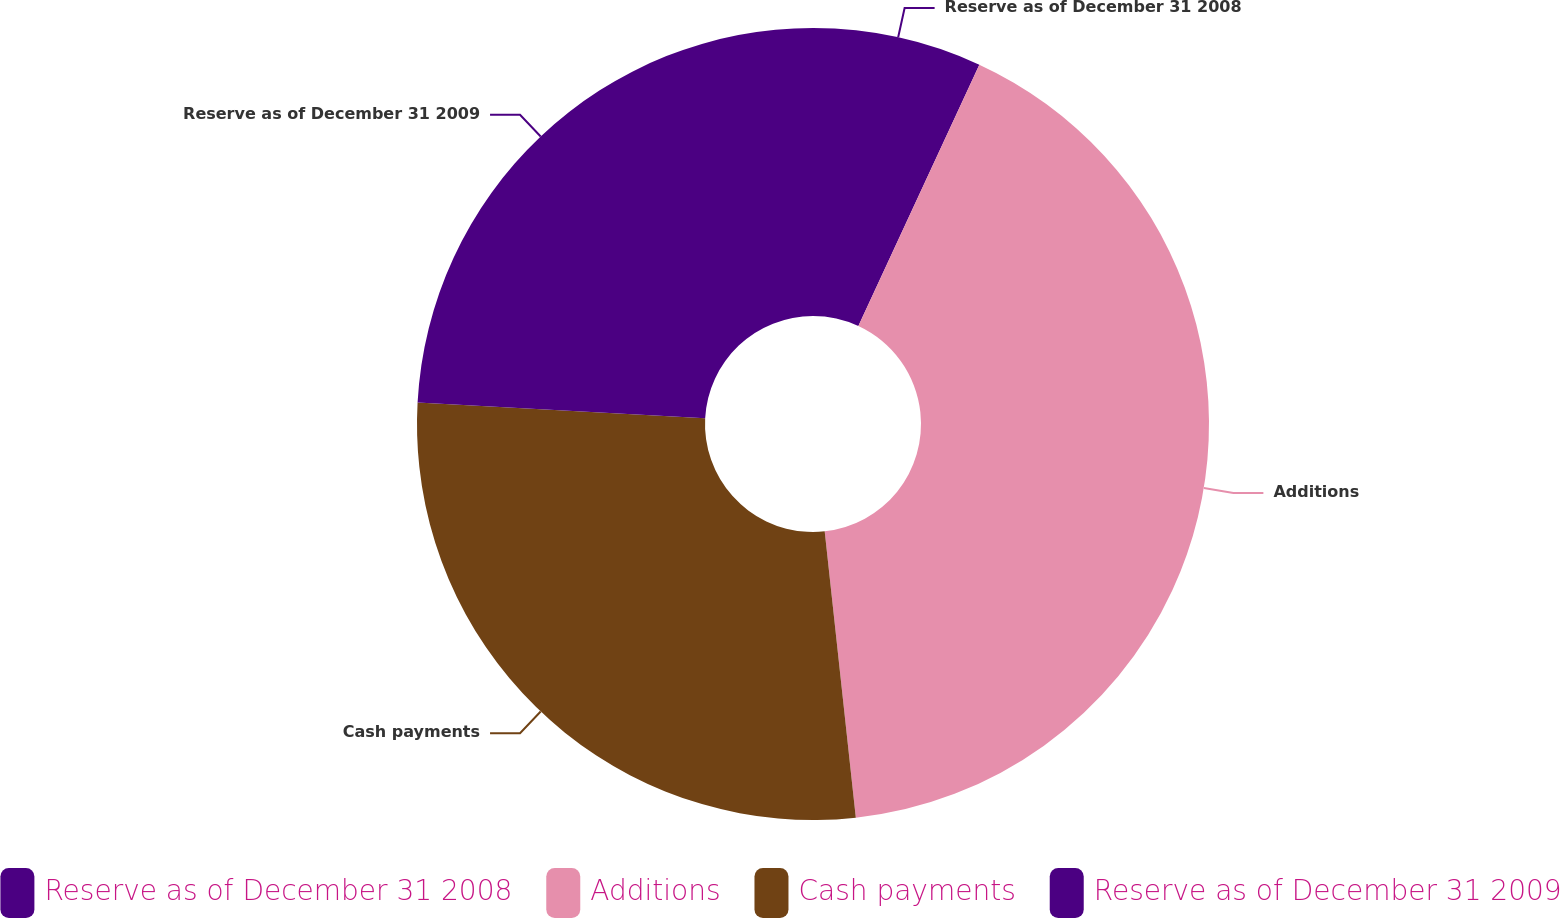Convert chart to OTSL. <chart><loc_0><loc_0><loc_500><loc_500><pie_chart><fcel>Reserve as of December 31 2008<fcel>Additions<fcel>Cash payments<fcel>Reserve as of December 31 2009<nl><fcel>6.9%<fcel>41.38%<fcel>27.59%<fcel>24.14%<nl></chart> 